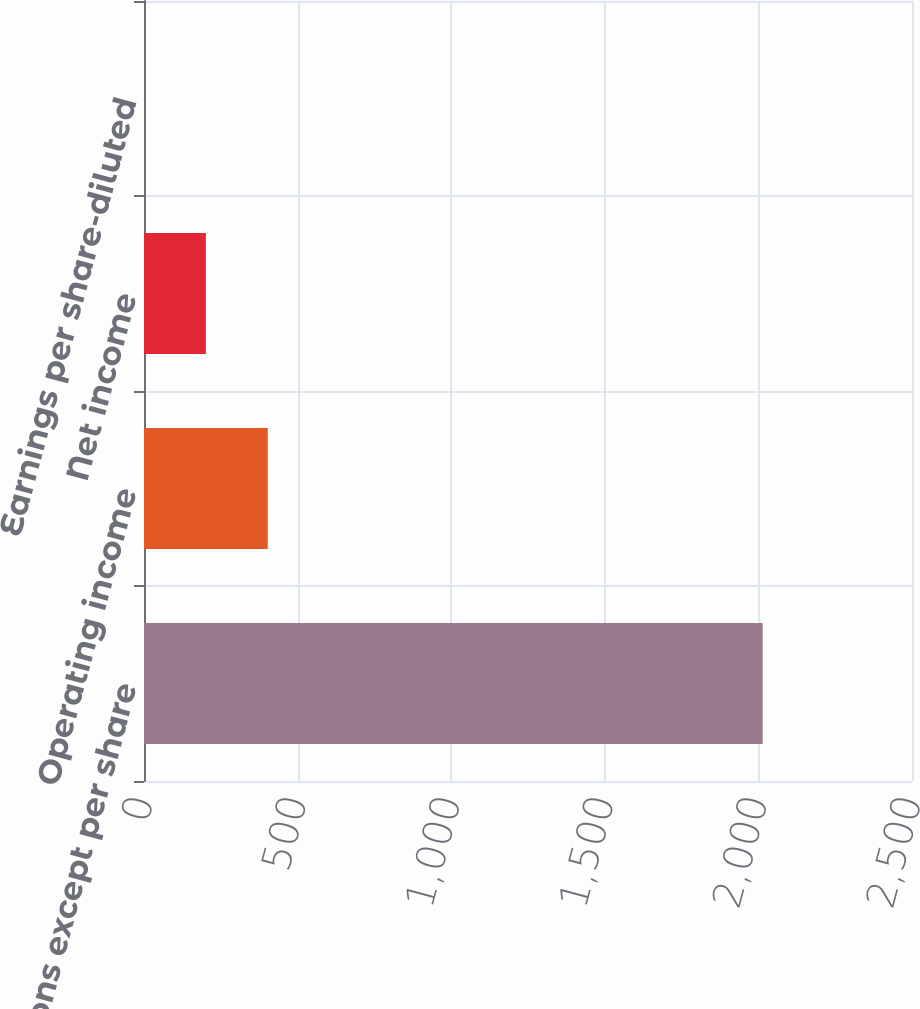Convert chart to OTSL. <chart><loc_0><loc_0><loc_500><loc_500><bar_chart><fcel>(millions except per share<fcel>Operating income<fcel>Net income<fcel>Earnings per share-diluted<nl><fcel>2014<fcel>402.83<fcel>201.43<fcel>0.03<nl></chart> 